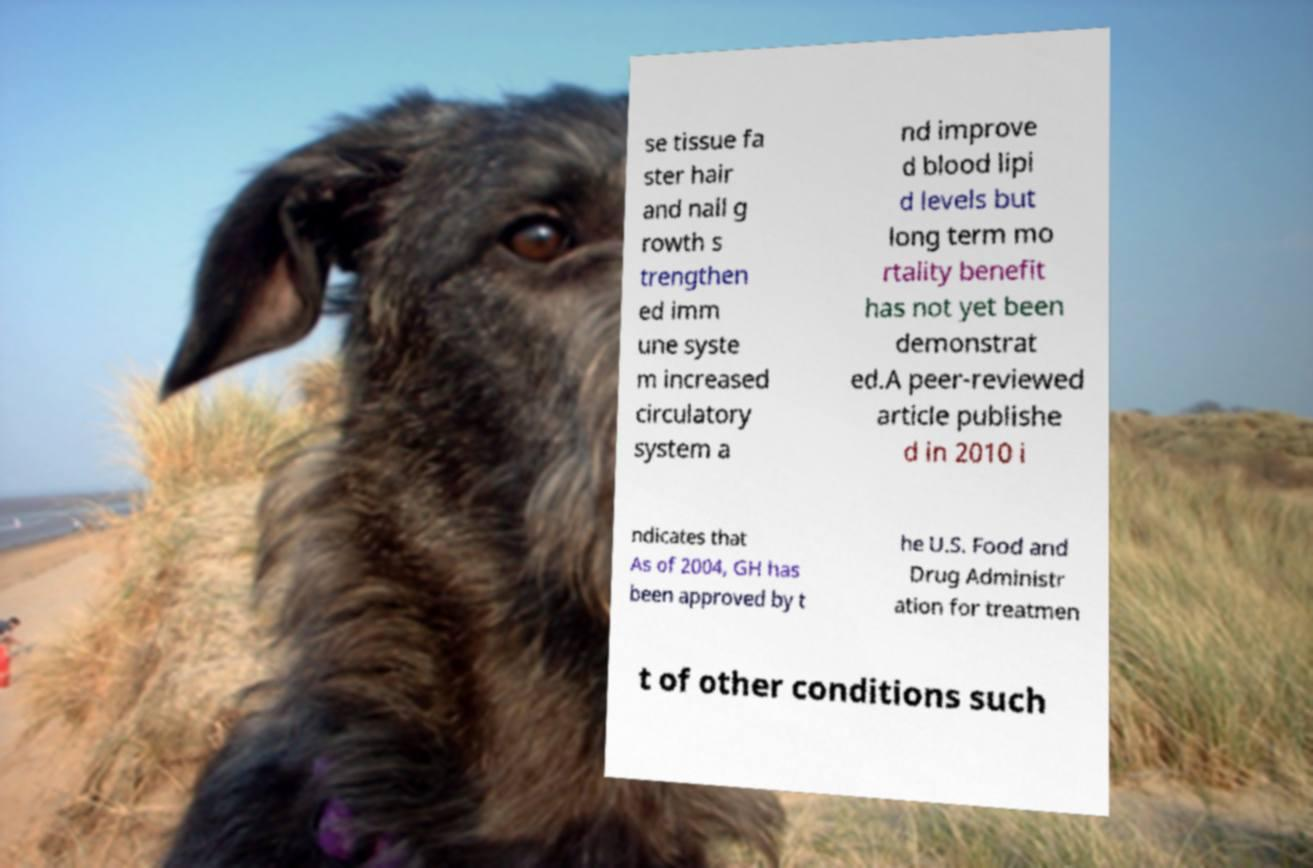Please read and relay the text visible in this image. What does it say? se tissue fa ster hair and nail g rowth s trengthen ed imm une syste m increased circulatory system a nd improve d blood lipi d levels but long term mo rtality benefit has not yet been demonstrat ed.A peer-reviewed article publishe d in 2010 i ndicates that As of 2004, GH has been approved by t he U.S. Food and Drug Administr ation for treatmen t of other conditions such 